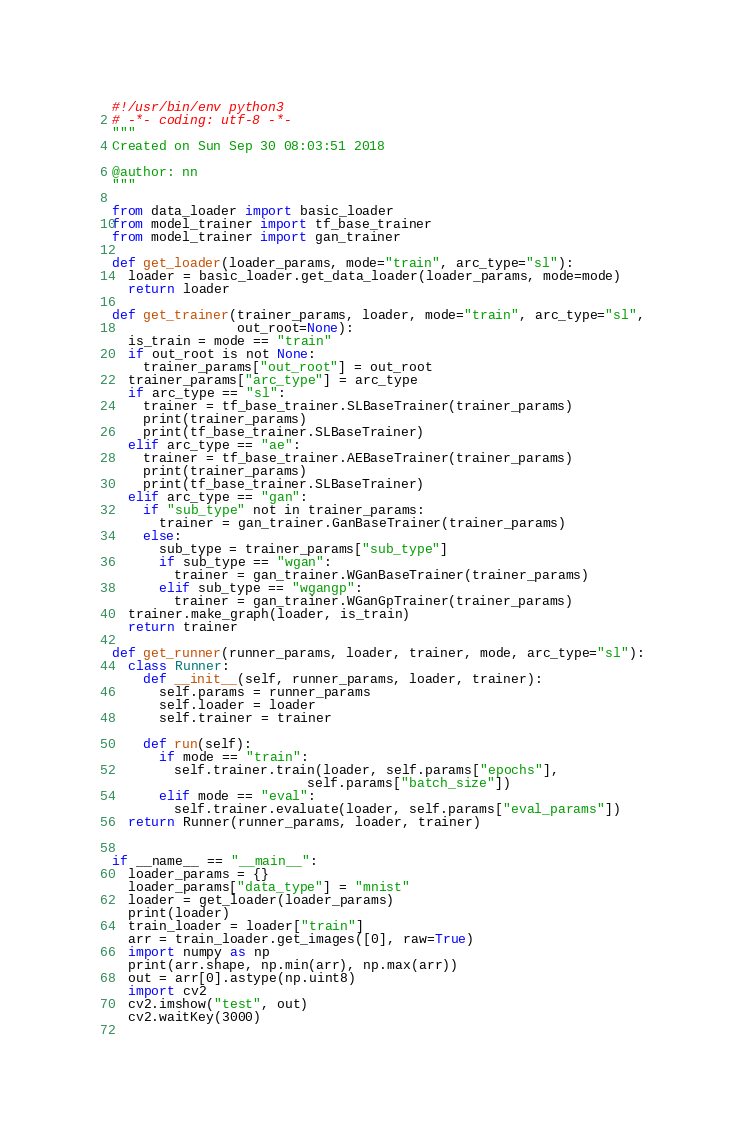Convert code to text. <code><loc_0><loc_0><loc_500><loc_500><_Python_>#!/usr/bin/env python3
# -*- coding: utf-8 -*-
"""
Created on Sun Sep 30 08:03:51 2018

@author: nn
"""

from data_loader import basic_loader
from model_trainer import tf_base_trainer
from model_trainer import gan_trainer

def get_loader(loader_params, mode="train", arc_type="sl"):
  loader = basic_loader.get_data_loader(loader_params, mode=mode)
  return loader

def get_trainer(trainer_params, loader, mode="train", arc_type="sl",
                out_root=None):
  is_train = mode == "train"
  if out_root is not None:
    trainer_params["out_root"] = out_root
  trainer_params["arc_type"] = arc_type
  if arc_type == "sl":    
    trainer = tf_base_trainer.SLBaseTrainer(trainer_params)
    print(trainer_params)
    print(tf_base_trainer.SLBaseTrainer)
  elif arc_type == "ae":
    trainer = tf_base_trainer.AEBaseTrainer(trainer_params)
    print(trainer_params)
    print(tf_base_trainer.SLBaseTrainer)    
  elif arc_type == "gan":
    if "sub_type" not in trainer_params:
      trainer = gan_trainer.GanBaseTrainer(trainer_params)
    else:
      sub_type = trainer_params["sub_type"]
      if sub_type == "wgan":
        trainer = gan_trainer.WGanBaseTrainer(trainer_params)
      elif sub_type == "wgangp":
        trainer = gan_trainer.WGanGpTrainer(trainer_params)
  trainer.make_graph(loader, is_train)
  return trainer

def get_runner(runner_params, loader, trainer, mode, arc_type="sl"):
  class Runner:
    def __init__(self, runner_params, loader, trainer):
      self.params = runner_params
      self.loader = loader
      self.trainer = trainer

    def run(self):
      if mode == "train":
        self.trainer.train(loader, self.params["epochs"],
                         self.params["batch_size"])
      elif mode == "eval":
        self.trainer.evaluate(loader, self.params["eval_params"])
  return Runner(runner_params, loader, trainer)
      

if __name__ == "__main__":
  loader_params = {}
  loader_params["data_type"] = "mnist"
  loader = get_loader(loader_params)
  print(loader)
  train_loader = loader["train"]
  arr = train_loader.get_images([0], raw=True)  
  import numpy as np
  print(arr.shape, np.min(arr), np.max(arr))
  out = arr[0].astype(np.uint8)
  import cv2
  cv2.imshow("test", out)
  cv2.waitKey(3000)
  </code> 